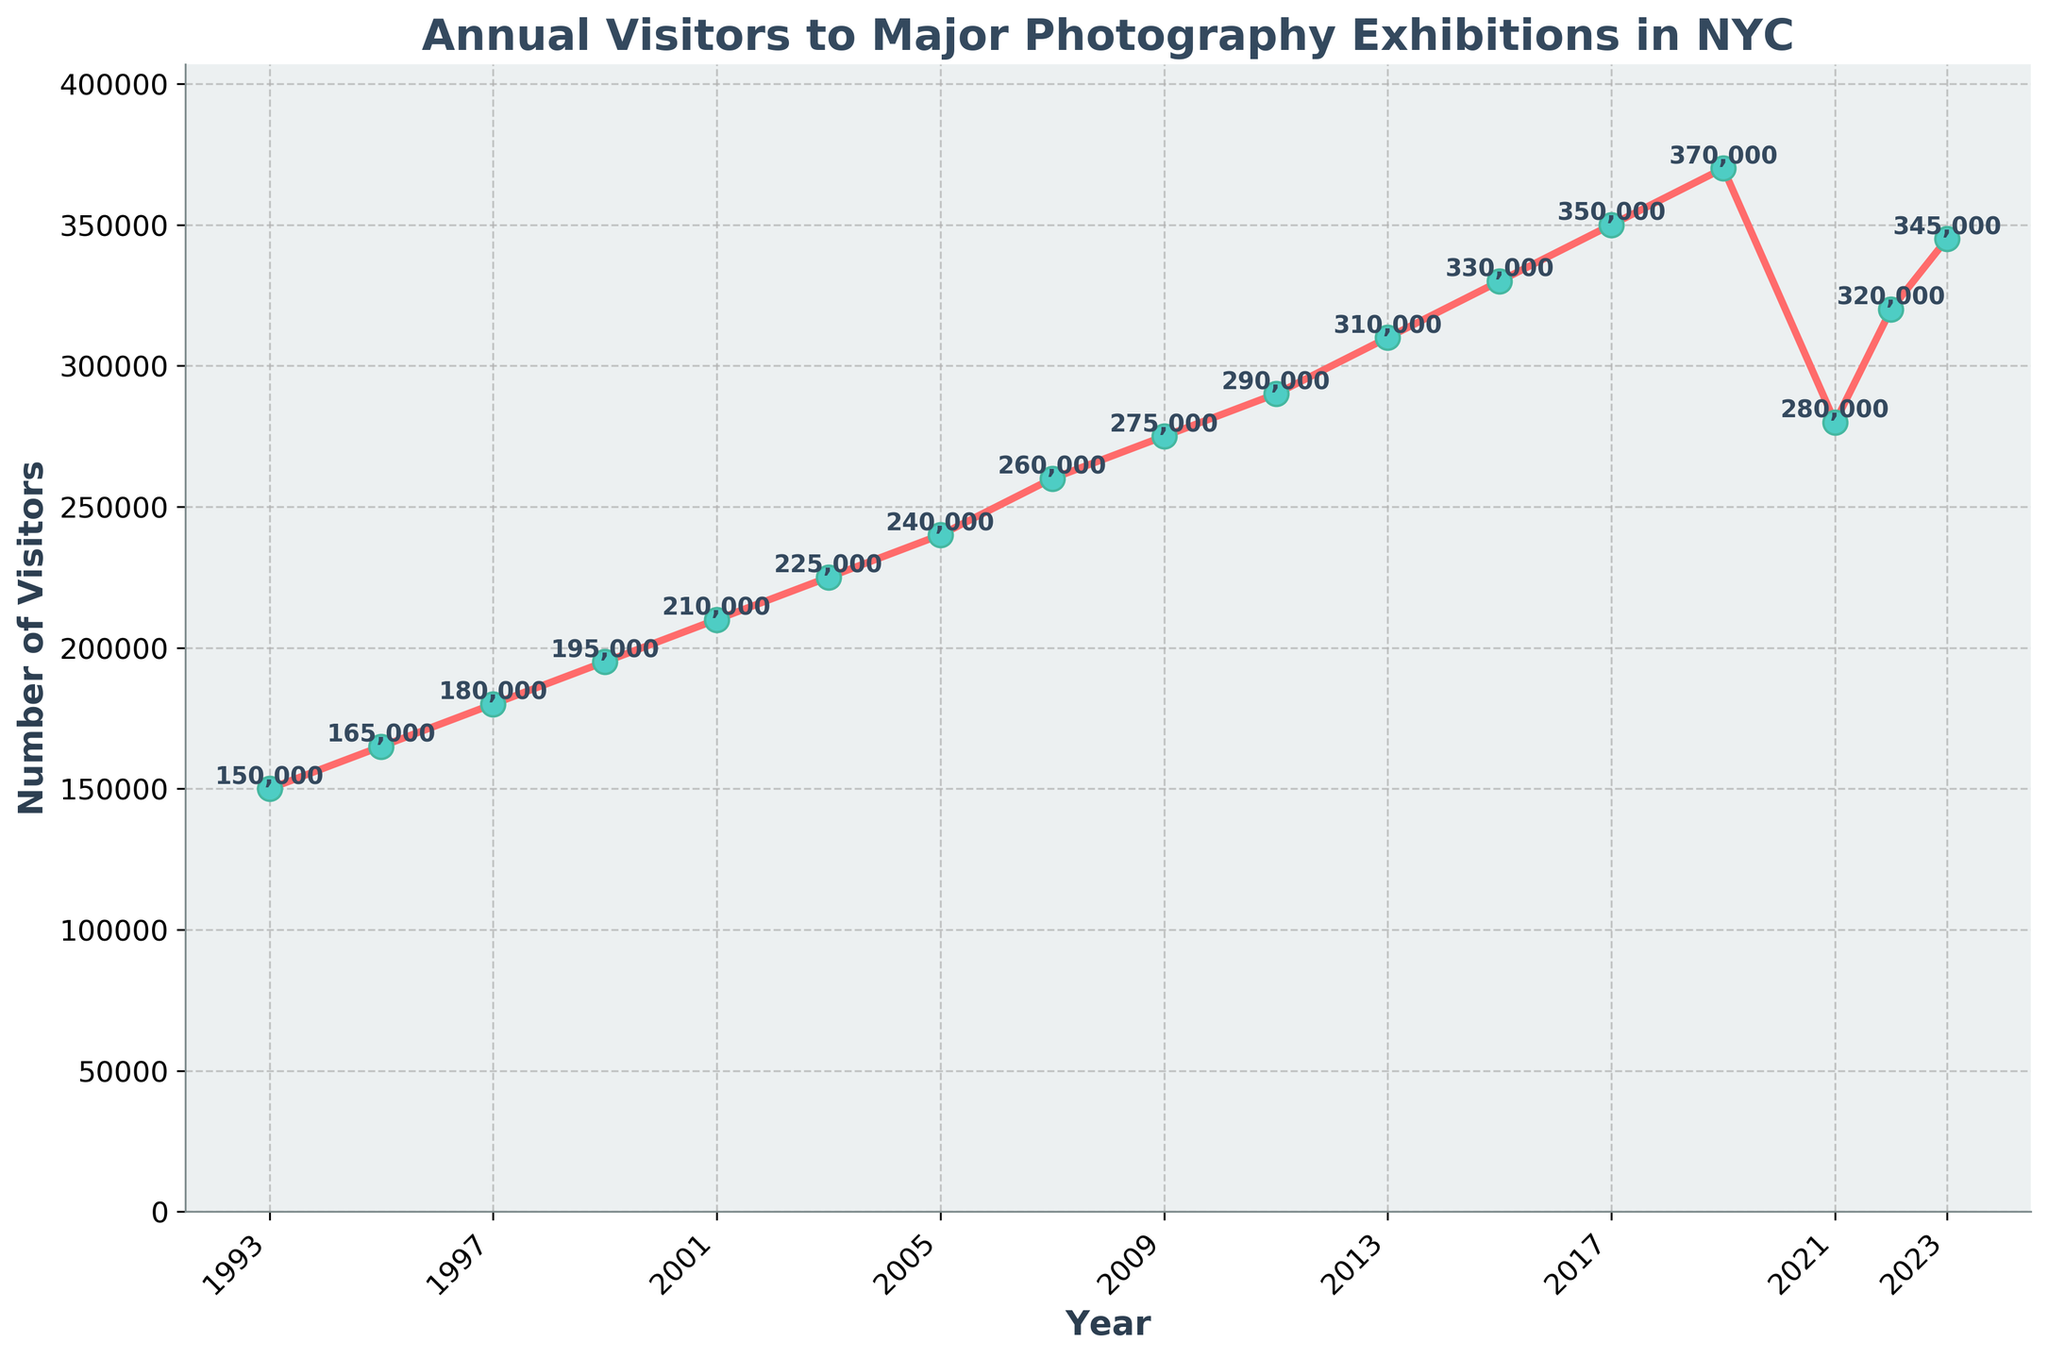How many visitors were there in 2023? Check the plotted line for the year 2023 and read the visitor number annotated next to or on top of the data point.
Answer: 345,000 What was the difference in visitor numbers between 2019 and 2021? Read the visitor numbers for 2019 (370,000) and 2021 (280,000). Subtract the 2021 number from the 2019 number: 370,000 - 280,000 = 90,000.
Answer: 90,000 What is the average number of visitors from 2017 to 2023? The visitor numbers from 2017 to 2023 are 350,000, 370,000, 280,000, 320,000, and 345,000. Sum these values (350,000 + 370,000 + 280,000 + 320,000 + 345,000 = 1,665,000) and divide by the number of years (5). The average is 1,665,000 / 5 = 333,000.
Answer: 333,000 In which year did visitor numbers reach 300,000 for the first time? Check the plotted data points to find the year where the visitor number first equals or exceeds 300,000.
Answer: 2013 Between which consecutive years was the greatest increase in visitor numbers, and what was the increase? Calculate the increase for each two-year period and find the maximum:  
(1995-1993: 165,000 - 150,000 = 15,000)  
(1997-1995: 180,000 - 165,000 = 15,000)  
(1999-1997: 195,000 - 180,000 = 15,000)   
(2001-1999: 210,000 - 195,000 = 15,000)  
(2003-2001: 225,000 - 210,000 = 15,000)  
(2005-2003: 240,000 - 225,000 = 15,000)  
(2007-2005: 260,000 - 240,000 = 20,000)  
(2009-2007: 275,000 - 260,000 = 15,000)  
(2011-2009: 290,000 - 275,000 = 15,000)  
(2013-2011: 310,000 - 290,000 = 20,000)  
(2015-2013: 330,000 - 310,000 = 20,000)  
(2017-2015: 350,000 - 330,000 = 20,000)  
(2019-2017: 370,000 - 350,000 = 20,000)  
(2021-2019: 280,000 - 370,000 = -90,000)  
(2022-2021: 320,000 - 280,000 = 40,000)  
(2023-2022: 345,000 - 320,000 = 25,000)  
The greatest increase is between 2021 and 2022 with an increase of 40,000 visitors.
Answer: 2021-2022, 40,000 Which year had the lowest visitor number, and what was it? Identify the lowest point on the plot and find the corresponding year and visitor number.
Answer: 1993, 150,000 How does the visitor number in 2023 compare to the visitor number in 2019? Compare the visitor numbers for 2023 (345,000) and 2019 (370,000). Note that the number in 2023 is lower.
Answer: 2023 visitor number is lower by 25,000 Identify the two years with the highest visitor numbers and state those numbers. Check the plot for the highest data points. The two highest visitor numbers are 370,000 in 2019 and 350,000 in 2017.
Answer: 2019: 370,000, 2017: 350,000 